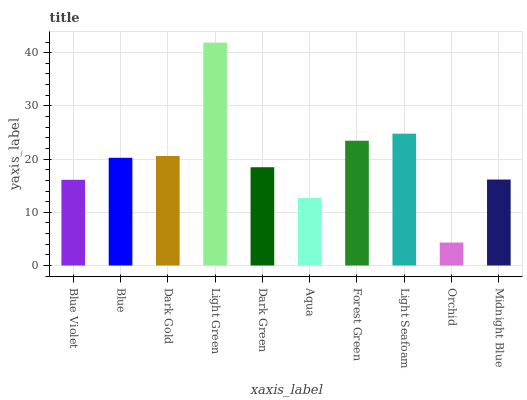Is Orchid the minimum?
Answer yes or no. Yes. Is Light Green the maximum?
Answer yes or no. Yes. Is Blue the minimum?
Answer yes or no. No. Is Blue the maximum?
Answer yes or no. No. Is Blue greater than Blue Violet?
Answer yes or no. Yes. Is Blue Violet less than Blue?
Answer yes or no. Yes. Is Blue Violet greater than Blue?
Answer yes or no. No. Is Blue less than Blue Violet?
Answer yes or no. No. Is Blue the high median?
Answer yes or no. Yes. Is Dark Green the low median?
Answer yes or no. Yes. Is Light Seafoam the high median?
Answer yes or no. No. Is Blue the low median?
Answer yes or no. No. 